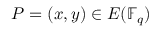<formula> <loc_0><loc_0><loc_500><loc_500>P = ( x , y ) \in E ( \mathbb { F } _ { q } )</formula> 